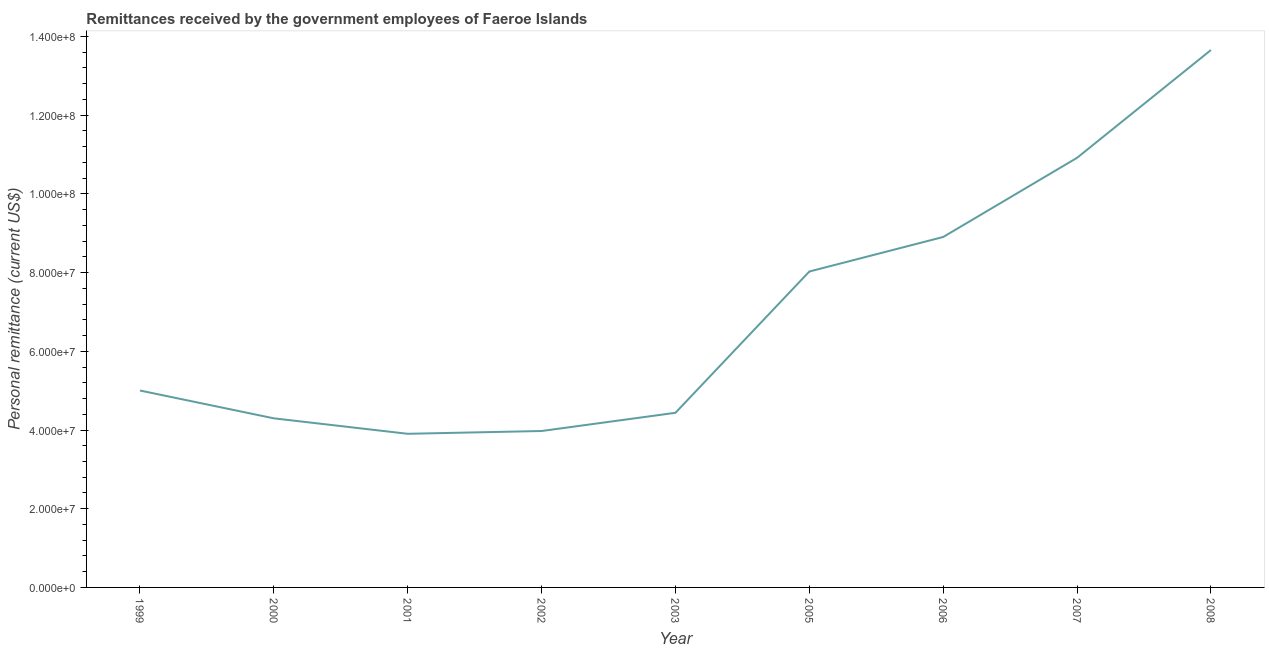What is the personal remittances in 2006?
Offer a terse response. 8.91e+07. Across all years, what is the maximum personal remittances?
Give a very brief answer. 1.37e+08. Across all years, what is the minimum personal remittances?
Your answer should be compact. 3.90e+07. In which year was the personal remittances maximum?
Offer a terse response. 2008. In which year was the personal remittances minimum?
Provide a short and direct response. 2001. What is the sum of the personal remittances?
Provide a succinct answer. 6.31e+08. What is the difference between the personal remittances in 2001 and 2006?
Offer a terse response. -5.00e+07. What is the average personal remittances per year?
Offer a terse response. 7.01e+07. What is the median personal remittances?
Provide a short and direct response. 5.00e+07. Do a majority of the years between 2001 and 2002 (inclusive) have personal remittances greater than 32000000 US$?
Your answer should be very brief. Yes. What is the ratio of the personal remittances in 2001 to that in 2002?
Make the answer very short. 0.98. What is the difference between the highest and the second highest personal remittances?
Offer a terse response. 2.74e+07. Is the sum of the personal remittances in 2003 and 2007 greater than the maximum personal remittances across all years?
Your response must be concise. Yes. What is the difference between the highest and the lowest personal remittances?
Offer a terse response. 9.75e+07. In how many years, is the personal remittances greater than the average personal remittances taken over all years?
Offer a terse response. 4. Are the values on the major ticks of Y-axis written in scientific E-notation?
Your response must be concise. Yes. Does the graph contain grids?
Keep it short and to the point. No. What is the title of the graph?
Your response must be concise. Remittances received by the government employees of Faeroe Islands. What is the label or title of the X-axis?
Your answer should be very brief. Year. What is the label or title of the Y-axis?
Offer a terse response. Personal remittance (current US$). What is the Personal remittance (current US$) in 1999?
Make the answer very short. 5.00e+07. What is the Personal remittance (current US$) in 2000?
Offer a very short reply. 4.30e+07. What is the Personal remittance (current US$) in 2001?
Offer a very short reply. 3.90e+07. What is the Personal remittance (current US$) in 2002?
Ensure brevity in your answer.  3.98e+07. What is the Personal remittance (current US$) of 2003?
Your answer should be very brief. 4.44e+07. What is the Personal remittance (current US$) in 2005?
Keep it short and to the point. 8.03e+07. What is the Personal remittance (current US$) in 2006?
Your response must be concise. 8.91e+07. What is the Personal remittance (current US$) of 2007?
Keep it short and to the point. 1.09e+08. What is the Personal remittance (current US$) of 2008?
Provide a succinct answer. 1.37e+08. What is the difference between the Personal remittance (current US$) in 1999 and 2000?
Offer a terse response. 7.07e+06. What is the difference between the Personal remittance (current US$) in 1999 and 2001?
Offer a very short reply. 1.10e+07. What is the difference between the Personal remittance (current US$) in 1999 and 2002?
Your answer should be very brief. 1.03e+07. What is the difference between the Personal remittance (current US$) in 1999 and 2003?
Keep it short and to the point. 5.66e+06. What is the difference between the Personal remittance (current US$) in 1999 and 2005?
Your answer should be very brief. -3.02e+07. What is the difference between the Personal remittance (current US$) in 1999 and 2006?
Provide a succinct answer. -3.90e+07. What is the difference between the Personal remittance (current US$) in 1999 and 2007?
Provide a short and direct response. -5.91e+07. What is the difference between the Personal remittance (current US$) in 1999 and 2008?
Give a very brief answer. -8.65e+07. What is the difference between the Personal remittance (current US$) in 2000 and 2001?
Ensure brevity in your answer.  3.93e+06. What is the difference between the Personal remittance (current US$) in 2000 and 2002?
Give a very brief answer. 3.22e+06. What is the difference between the Personal remittance (current US$) in 2000 and 2003?
Your response must be concise. -1.41e+06. What is the difference between the Personal remittance (current US$) in 2000 and 2005?
Your answer should be very brief. -3.73e+07. What is the difference between the Personal remittance (current US$) in 2000 and 2006?
Ensure brevity in your answer.  -4.61e+07. What is the difference between the Personal remittance (current US$) in 2000 and 2007?
Offer a terse response. -6.62e+07. What is the difference between the Personal remittance (current US$) in 2000 and 2008?
Offer a terse response. -9.36e+07. What is the difference between the Personal remittance (current US$) in 2001 and 2002?
Your response must be concise. -7.10e+05. What is the difference between the Personal remittance (current US$) in 2001 and 2003?
Your answer should be compact. -5.34e+06. What is the difference between the Personal remittance (current US$) in 2001 and 2005?
Keep it short and to the point. -4.12e+07. What is the difference between the Personal remittance (current US$) in 2001 and 2006?
Your response must be concise. -5.00e+07. What is the difference between the Personal remittance (current US$) in 2001 and 2007?
Your answer should be compact. -7.01e+07. What is the difference between the Personal remittance (current US$) in 2001 and 2008?
Offer a very short reply. -9.75e+07. What is the difference between the Personal remittance (current US$) in 2002 and 2003?
Provide a succinct answer. -4.63e+06. What is the difference between the Personal remittance (current US$) in 2002 and 2005?
Provide a succinct answer. -4.05e+07. What is the difference between the Personal remittance (current US$) in 2002 and 2006?
Offer a terse response. -4.93e+07. What is the difference between the Personal remittance (current US$) in 2002 and 2007?
Give a very brief answer. -6.94e+07. What is the difference between the Personal remittance (current US$) in 2002 and 2008?
Offer a very short reply. -9.68e+07. What is the difference between the Personal remittance (current US$) in 2003 and 2005?
Offer a terse response. -3.59e+07. What is the difference between the Personal remittance (current US$) in 2003 and 2006?
Your answer should be compact. -4.47e+07. What is the difference between the Personal remittance (current US$) in 2003 and 2007?
Your answer should be compact. -6.48e+07. What is the difference between the Personal remittance (current US$) in 2003 and 2008?
Make the answer very short. -9.22e+07. What is the difference between the Personal remittance (current US$) in 2005 and 2006?
Keep it short and to the point. -8.77e+06. What is the difference between the Personal remittance (current US$) in 2005 and 2007?
Your answer should be compact. -2.89e+07. What is the difference between the Personal remittance (current US$) in 2005 and 2008?
Offer a terse response. -5.63e+07. What is the difference between the Personal remittance (current US$) in 2006 and 2007?
Offer a terse response. -2.01e+07. What is the difference between the Personal remittance (current US$) in 2006 and 2008?
Offer a terse response. -4.75e+07. What is the difference between the Personal remittance (current US$) in 2007 and 2008?
Your answer should be very brief. -2.74e+07. What is the ratio of the Personal remittance (current US$) in 1999 to that in 2000?
Your answer should be compact. 1.17. What is the ratio of the Personal remittance (current US$) in 1999 to that in 2001?
Ensure brevity in your answer.  1.28. What is the ratio of the Personal remittance (current US$) in 1999 to that in 2002?
Keep it short and to the point. 1.26. What is the ratio of the Personal remittance (current US$) in 1999 to that in 2003?
Give a very brief answer. 1.13. What is the ratio of the Personal remittance (current US$) in 1999 to that in 2005?
Your answer should be very brief. 0.62. What is the ratio of the Personal remittance (current US$) in 1999 to that in 2006?
Your answer should be very brief. 0.56. What is the ratio of the Personal remittance (current US$) in 1999 to that in 2007?
Provide a succinct answer. 0.46. What is the ratio of the Personal remittance (current US$) in 1999 to that in 2008?
Your answer should be compact. 0.37. What is the ratio of the Personal remittance (current US$) in 2000 to that in 2001?
Ensure brevity in your answer.  1.1. What is the ratio of the Personal remittance (current US$) in 2000 to that in 2002?
Provide a succinct answer. 1.08. What is the ratio of the Personal remittance (current US$) in 2000 to that in 2003?
Ensure brevity in your answer.  0.97. What is the ratio of the Personal remittance (current US$) in 2000 to that in 2005?
Offer a very short reply. 0.54. What is the ratio of the Personal remittance (current US$) in 2000 to that in 2006?
Offer a very short reply. 0.48. What is the ratio of the Personal remittance (current US$) in 2000 to that in 2007?
Provide a succinct answer. 0.39. What is the ratio of the Personal remittance (current US$) in 2000 to that in 2008?
Offer a terse response. 0.32. What is the ratio of the Personal remittance (current US$) in 2001 to that in 2003?
Provide a short and direct response. 0.88. What is the ratio of the Personal remittance (current US$) in 2001 to that in 2005?
Make the answer very short. 0.49. What is the ratio of the Personal remittance (current US$) in 2001 to that in 2006?
Your answer should be very brief. 0.44. What is the ratio of the Personal remittance (current US$) in 2001 to that in 2007?
Offer a very short reply. 0.36. What is the ratio of the Personal remittance (current US$) in 2001 to that in 2008?
Offer a very short reply. 0.29. What is the ratio of the Personal remittance (current US$) in 2002 to that in 2003?
Provide a succinct answer. 0.9. What is the ratio of the Personal remittance (current US$) in 2002 to that in 2005?
Offer a very short reply. 0.49. What is the ratio of the Personal remittance (current US$) in 2002 to that in 2006?
Make the answer very short. 0.45. What is the ratio of the Personal remittance (current US$) in 2002 to that in 2007?
Keep it short and to the point. 0.36. What is the ratio of the Personal remittance (current US$) in 2002 to that in 2008?
Give a very brief answer. 0.29. What is the ratio of the Personal remittance (current US$) in 2003 to that in 2005?
Keep it short and to the point. 0.55. What is the ratio of the Personal remittance (current US$) in 2003 to that in 2006?
Offer a terse response. 0.5. What is the ratio of the Personal remittance (current US$) in 2003 to that in 2007?
Your response must be concise. 0.41. What is the ratio of the Personal remittance (current US$) in 2003 to that in 2008?
Offer a very short reply. 0.33. What is the ratio of the Personal remittance (current US$) in 2005 to that in 2006?
Make the answer very short. 0.9. What is the ratio of the Personal remittance (current US$) in 2005 to that in 2007?
Offer a very short reply. 0.73. What is the ratio of the Personal remittance (current US$) in 2005 to that in 2008?
Offer a very short reply. 0.59. What is the ratio of the Personal remittance (current US$) in 2006 to that in 2007?
Your answer should be very brief. 0.82. What is the ratio of the Personal remittance (current US$) in 2006 to that in 2008?
Provide a short and direct response. 0.65. What is the ratio of the Personal remittance (current US$) in 2007 to that in 2008?
Ensure brevity in your answer.  0.8. 